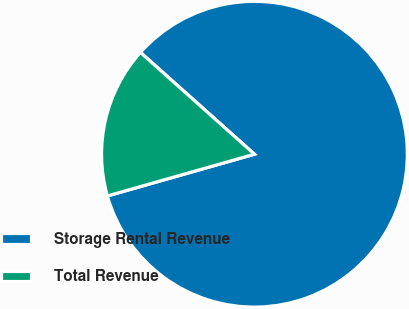Convert chart. <chart><loc_0><loc_0><loc_500><loc_500><pie_chart><fcel>Storage Rental Revenue<fcel>Total Revenue<nl><fcel>84.0%<fcel>16.0%<nl></chart> 